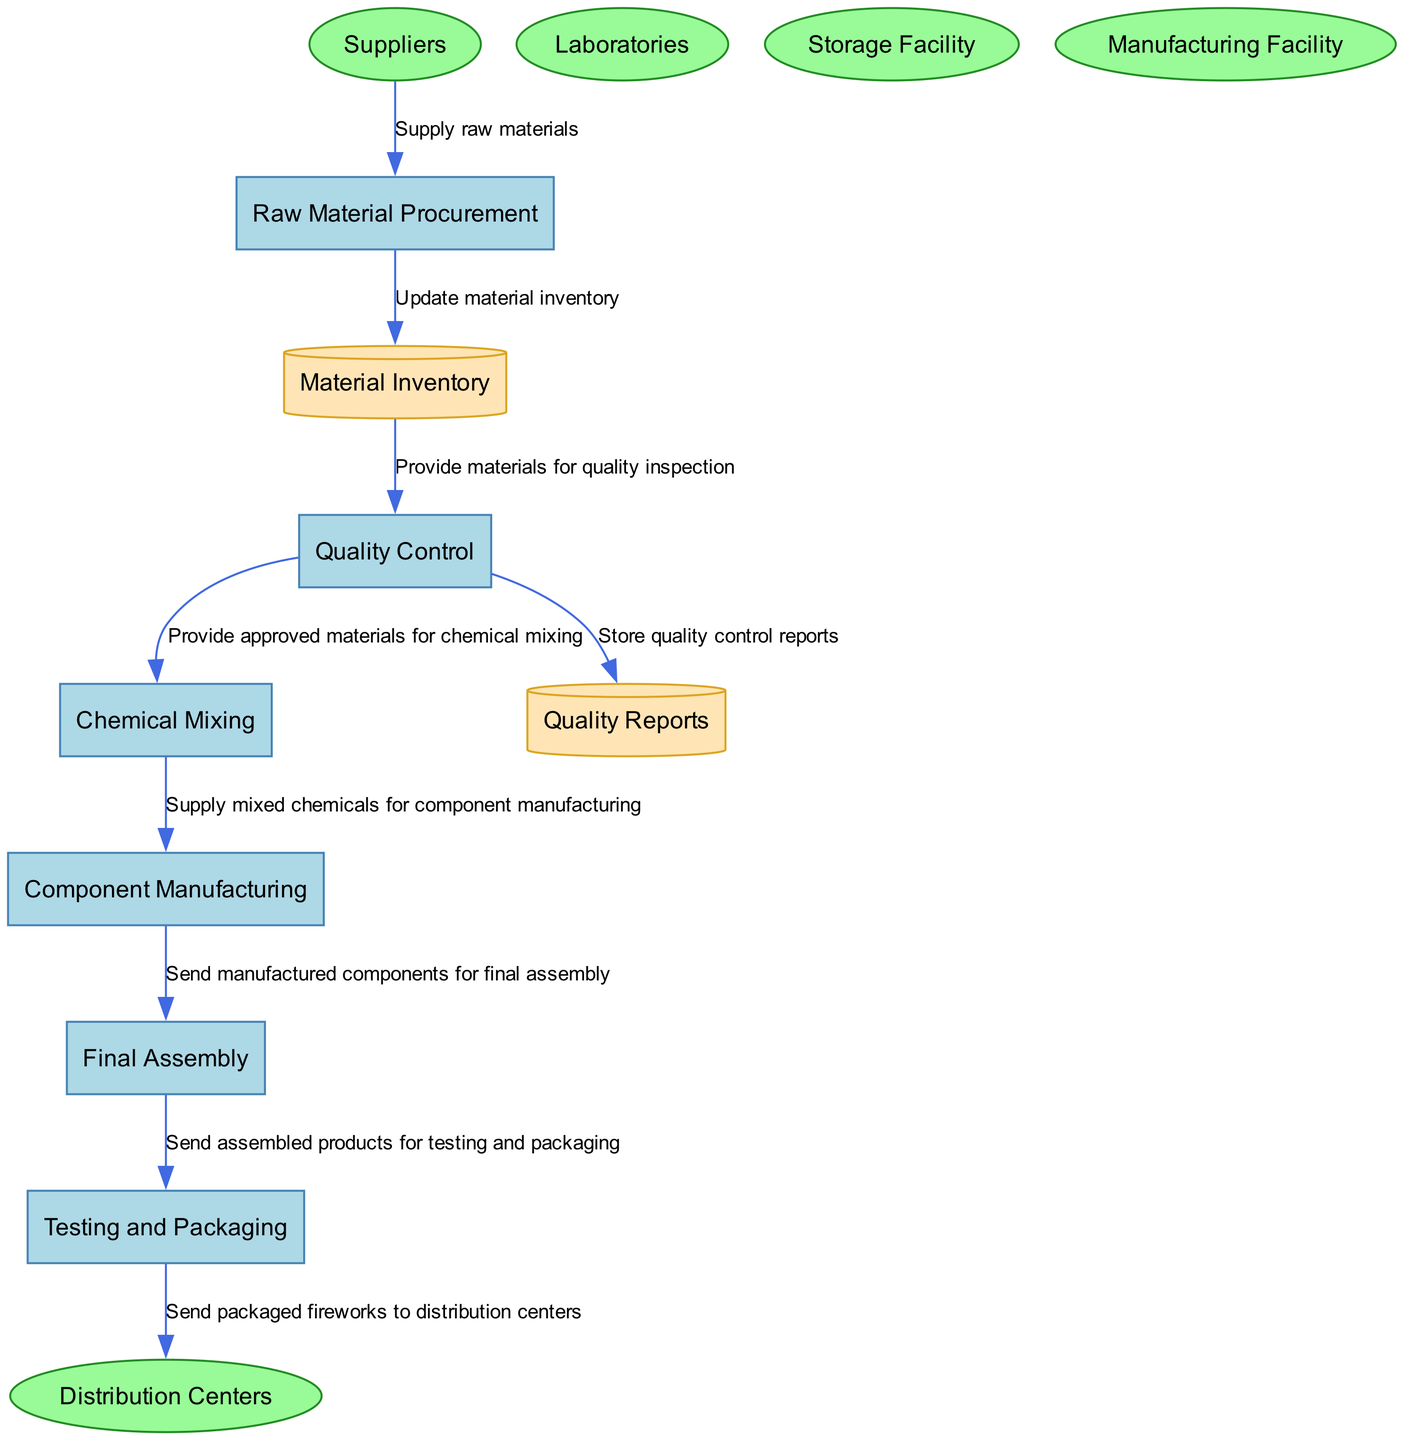What is the first process in the supply chain? The first process listed in the diagram is "Raw Material Procurement," indicated as P1. This process involves procuring the necessary raw materials for pyrotechnics.
Answer: Raw Material Procurement How many processes are represented in the diagram? By counting the entries categorized under "processes," we find there are six distinct processes from procurement to packaging.
Answer: Six Which entity is responsible for providing raw materials? The entity labeled "Suppliers," identified as E1 in the diagram, supplies the raw materials necessary for pyrotechnic compositions.
Answer: Suppliers What data store contains quality reports? The data store indicated as D2 is designated for storing quality control reports, as stated in the description for that data store.
Answer: Quality Reports After quality control, where do approved materials go? Approved materials move from the "Quality Control" process, P2, to "Chemical Mixing," which is represented as P3 in the diagram, forming a sequential flow.
Answer: Chemical Mixing What is the last process before distribution? The last process before the fireworks are sent to distribution centers is "Testing and Packaging," referenced as P6 in the diagram, ensuring safety and performance.
Answer: Testing and Packaging How do materials flow from procurement to inventory? The flow begins with suppliers supplying raw materials to the "Raw Material Procurement" process (P1), which then updates the "Material Inventory" data store (D1) after acquiring the materials.
Answer: Supply raw materials Which two processes are directly connected to "Chemical Mixing"? "Quality Control" (P2) feeds approved materials into "Chemical Mixing" (P3) after quality checks, while "Chemical Mixing" (P3) supplies mixed chemicals to "Component Manufacturing" (P4).
Answer: Quality Control and Component Manufacturing What type of facility handles the final assembly? The "Manufacturing Facility," labeled as E4 in the diagram, is responsible for the final assembly of fireworks products, as indicated by the connection from the final assembly process, P5.
Answer: Manufacturing Facility 